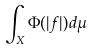<formula> <loc_0><loc_0><loc_500><loc_500>\int _ { X } \Phi ( | f | ) d \mu</formula> 